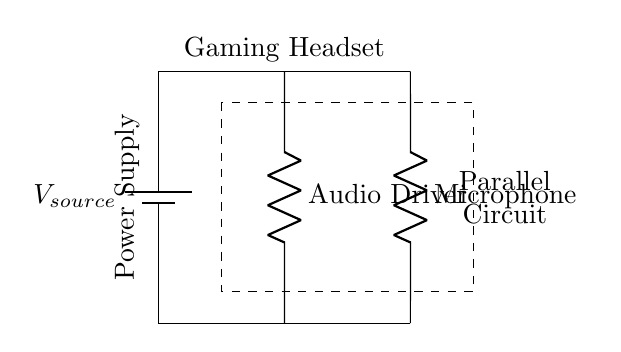What components are in the parallel circuit? The circuit includes an audio driver and a microphone, which are the two resistive components connected parallel to the power supply voltage.
Answer: Audio driver and microphone What is the purpose of the battery in this diagram? The battery serves as the power supply for the circuit, providing the necessary voltage to power both components connected in parallel.
Answer: Power supply How many resistive components are connected in this circuit? There are two resistive components visible in the circuit diagram, which are the audio driver and the microphone.
Answer: Two Which component is connected to the microphone? The microphone is connected directly to the power supply along the same parallel route as the audio driver.
Answer: Power supply What type of circuit is represented in this diagram? The diagram represents a parallel circuit, indicated by the manner of the connections where both components share the same voltage source.
Answer: Parallel circuit How does the voltage across the audio driver compare to the voltage across the microphone? In a parallel circuit, the voltage across both components is the same and equal to the source voltage, thus they share the same voltage level.
Answer: Same What happens to the individual current flowing through each component? In a parallel configuration, the total current is split between the components; thus, each component has its own individual current according to their resistance values.
Answer: Split 